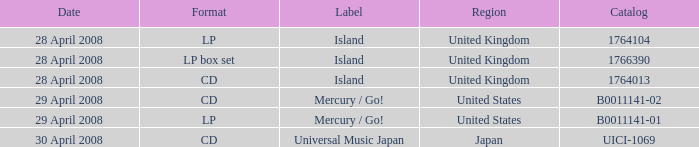What is the Region of the 1766390 Catalog? United Kingdom. 